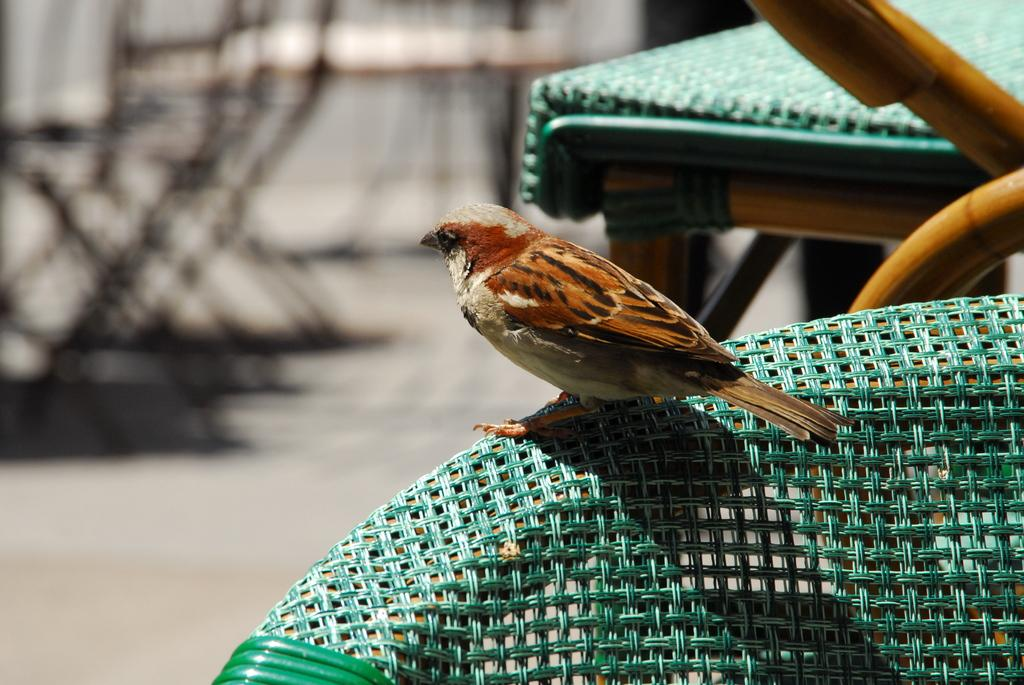What is sitting on the chair in the image? There is a bird on a chair in the image. What type of material are the poles made of in the image? The wooden poles are visible in the image. What piece of furniture is present in the image? There is a table in the image. How does the bird copy the movements of the earth in the image? The bird does not copy the movements of the earth in the image; it is simply sitting on a chair. What type of bit is the bird holding in its beak in the image? There is no bit present in the image; the bird is not holding anything in its beak. 